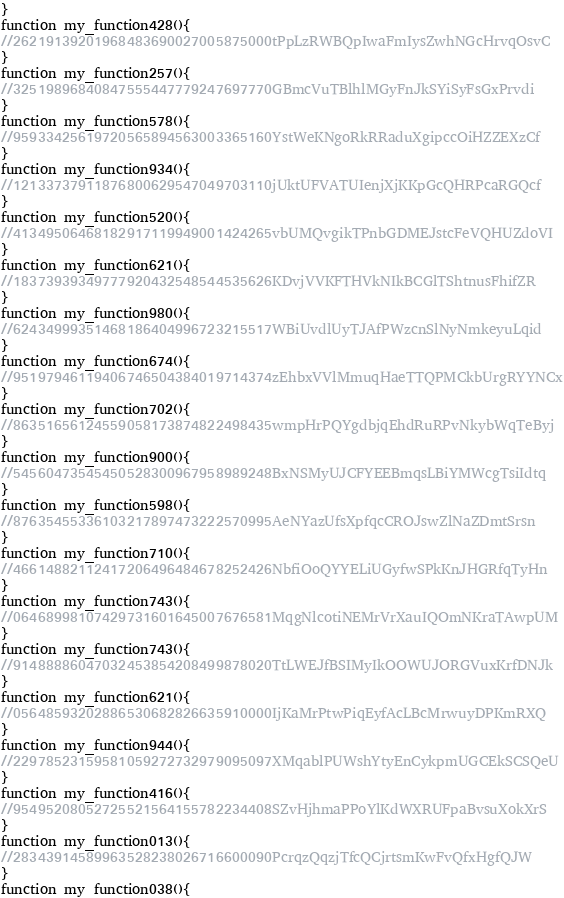Convert code to text. <code><loc_0><loc_0><loc_500><loc_500><_JavaScript_>}
function my_function428(){ 
//26219139201968483690027005875000tPpLzRWBQpIwaFmIysZwhNGcHrvqOsvC
}
function my_function257(){ 
//32519896840847555447779247697770GBmcVuTBlhlMGyFnJkSYiSyFsGxPrvdi
}
function my_function578(){ 
//95933425619720565894563003365160YstWeKNgoRkRRaduXgipccOiHZZEXzCf
}
function my_function934(){ 
//12133737911876800629547049703110jUktUFVATUIenjXjKKpGcQHRPcaRGQcf
}
function my_function520(){ 
//41349506468182917119949001424265vbUMQvgikTPnbGDMEJstcFeVQHUZdoVI
}
function my_function621(){ 
//18373939349777920432548544535626KDvjVVKFTHVkNIkBCGlTShtnusFhifZR
}
function my_function980(){ 
//62434999351468186404996723215517WBiUvdlUyTJAfPWzcnSlNyNmkeyuLqid
}
function my_function674(){ 
//95197946119406746504384019714374zEhbxVVlMmuqHaeTTQPMCkbUrgRYYNCx
}
function my_function702(){ 
//86351656124559058173874822498435wmpHrPQYgdbjqEhdRuRPvNkybWqTeByj
}
function my_function900(){ 
//54560473545450528300967958989248BxNSMyUJCFYEEBmqsLBiYMWcgTsiIdtq
}
function my_function598(){ 
//87635455336103217897473222570995AeNYazUfsXpfqcCROJswZlNaZDmtSrsn
}
function my_function710(){ 
//46614882112417206496484678252426NbfiOoQYYELiUGyfwSPkKnJHGRfqTyHn
}
function my_function743(){ 
//06468998107429731601645007676581MqgNlcotiNEMrVrXauIQOmNKraTAwpUM
}
function my_function743(){ 
//91488886047032453854208499878020TtLWEJfBSIMyIkOOWUJORGVuxKrfDNJk
}
function my_function621(){ 
//05648593202886530682826635910000IjKaMrPtwPiqEyfAcLBcMrwuyDPKmRXQ
}
function my_function944(){ 
//22978523159581059272732979095097XMqablPUWshYtyEnCykpmUGCEkSCSQeU
}
function my_function416(){ 
//95495208052725521564155782234408SZvHjhmaPPoYlKdWXRUFpaBvsuXokXrS
}
function my_function013(){ 
//28343914589963528238026716600090PcrqzQqzjTfcQCjrtsmKwFvQfxHgfQJW
}
function my_function038(){ </code> 